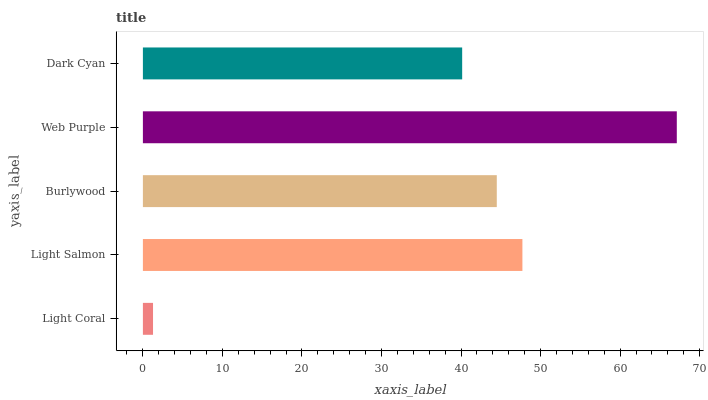Is Light Coral the minimum?
Answer yes or no. Yes. Is Web Purple the maximum?
Answer yes or no. Yes. Is Light Salmon the minimum?
Answer yes or no. No. Is Light Salmon the maximum?
Answer yes or no. No. Is Light Salmon greater than Light Coral?
Answer yes or no. Yes. Is Light Coral less than Light Salmon?
Answer yes or no. Yes. Is Light Coral greater than Light Salmon?
Answer yes or no. No. Is Light Salmon less than Light Coral?
Answer yes or no. No. Is Burlywood the high median?
Answer yes or no. Yes. Is Burlywood the low median?
Answer yes or no. Yes. Is Light Coral the high median?
Answer yes or no. No. Is Dark Cyan the low median?
Answer yes or no. No. 